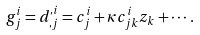<formula> <loc_0><loc_0><loc_500><loc_500>g _ { j } ^ { i } = d _ { , j } ^ { , i } = c _ { j } ^ { i } + \kappa c _ { j k } ^ { i } z _ { k } + \cdots .</formula> 